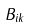Convert formula to latex. <formula><loc_0><loc_0><loc_500><loc_500>B _ { i k }</formula> 